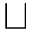<formula> <loc_0><loc_0><loc_500><loc_500>\sqcup</formula> 